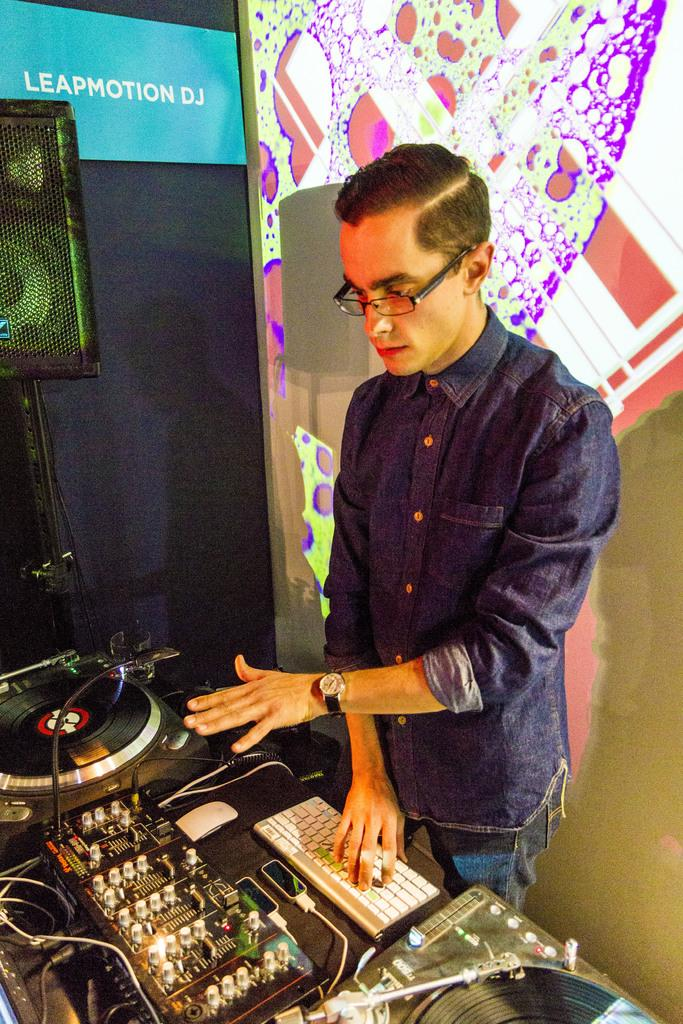What type of furniture is in the image? There is a table in the image. What is placed on the table? A keyboard and musical instruments are on the table. Who is near the table? There is a man standing near the table. What can be seen in the background of the image? There is a wall and a speaker in the background of the image. What type of umbrella is the man holding in the image? There is no umbrella present in the image; the man is not holding anything. How many fingers does the man have on his left hand in the image? We cannot determine the number of fingers the man has on his left hand from the image, as it does not provide enough detail. 